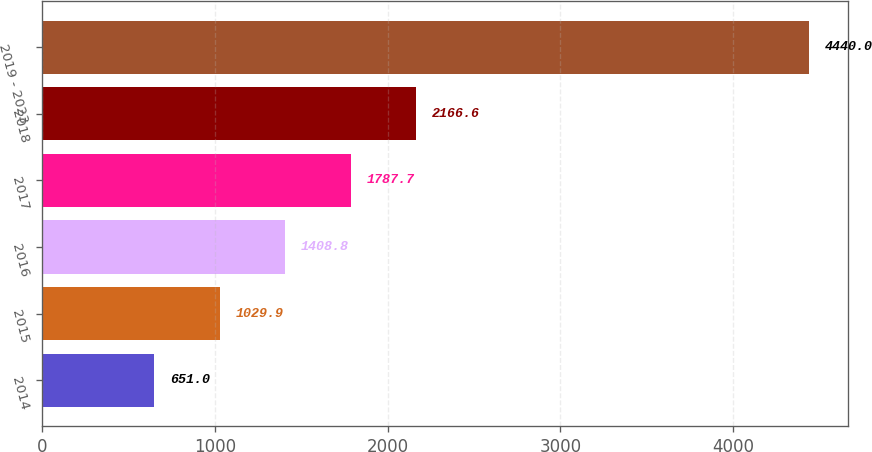Convert chart. <chart><loc_0><loc_0><loc_500><loc_500><bar_chart><fcel>2014<fcel>2015<fcel>2016<fcel>2017<fcel>2018<fcel>2019 - 2023<nl><fcel>651<fcel>1029.9<fcel>1408.8<fcel>1787.7<fcel>2166.6<fcel>4440<nl></chart> 